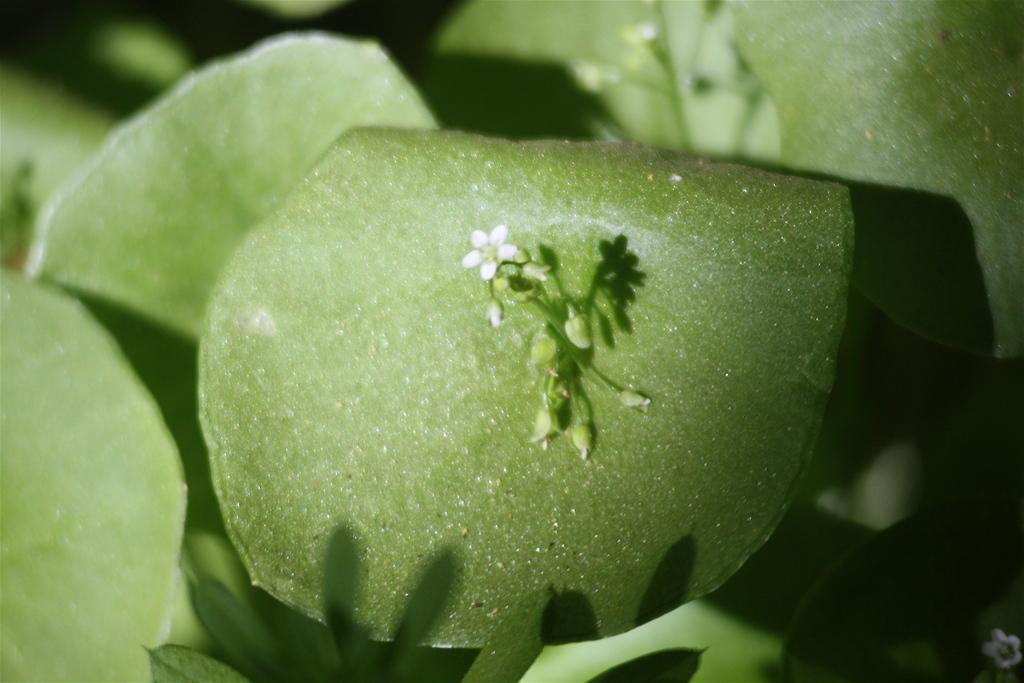What is the main subject of the image? The main subject of the image is a plant. Can you describe the plant in more detail? The image is a zoomed-in picture of a plant, and there is a flower in the middle of the image. What type of wool is used to create the title of the image? There is no wool or title present in the image, as it is a photograph of a plant with a flower. 